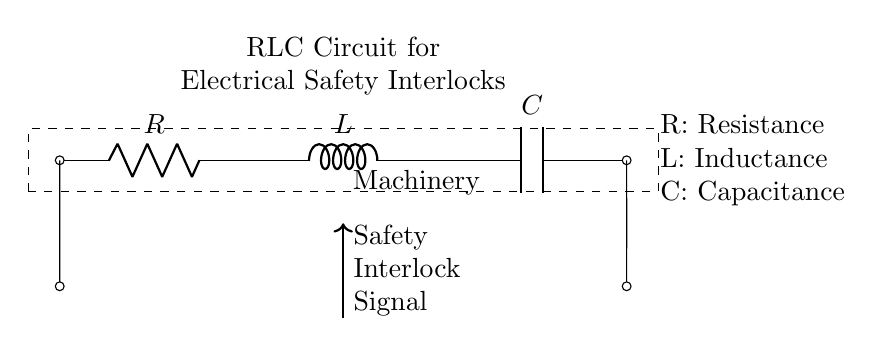What components are present in this circuit? The circuit has three components: a resistor, an inductor, and a capacitor. These components are standard in RLC circuit configurations.
Answer: Resistor, Inductor, Capacitor What is the purpose of the safety interlock signal? The safety interlock signal is used to ensure that the machinery operates safely by controlling the flow of current and preventing accidental activation. In essence, it acts as a precaution in machinery design.
Answer: Safety Interlock Signal How many terminals are available for connection in this circuit? There are four terminals visible: two at the ends (for input/output) and one at each component for connections.
Answer: Four What does "R" stand for in this circuit? "R" stands for Resistance, which indicates how much the resistor opposes the flow of current. Resistance is measured in ohms.
Answer: Resistance What effect does the inductor have in this circuit during current change? The inductor opposes changes in current due to its property of inductance, thereby affecting how quickly the current can rise or fall. This is important for electrical safety interlocks as it helps prevent abrupt changes that can damage machinery.
Answer: Opposes current change Why is it important to have all three components (R, L, C) in a safety interlock circuit? All three components work together to filter signals, provide stability, and improve transient response of the circuit, ensuring safer operations and preventing failures in machinery. This cooperation is essential for achieving reliable safety interlocks.
Answer: Stability, Filtering, Transient response 